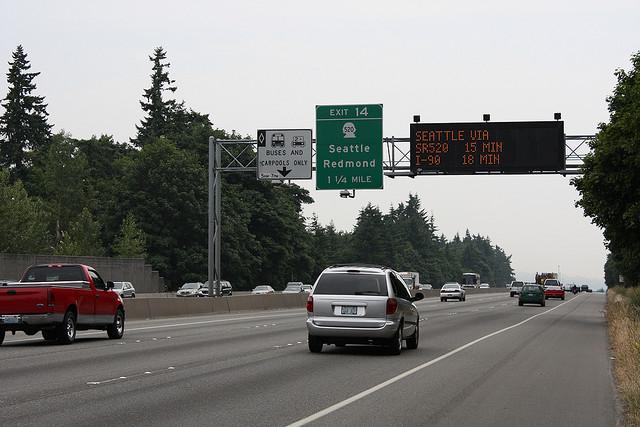How many cars are in the express lane?
Short answer required. 1. How far away is W 130th St?
Give a very brief answer. Unknown. What is the speed limit for the right three lanes?
Quick response, please. 55. What state is this picture taken based on the sign?
Short answer required. Washington. How many minutes until the van reaches I-90?
Concise answer only. 18. What city is on the middle sign?
Quick response, please. Seattle. 